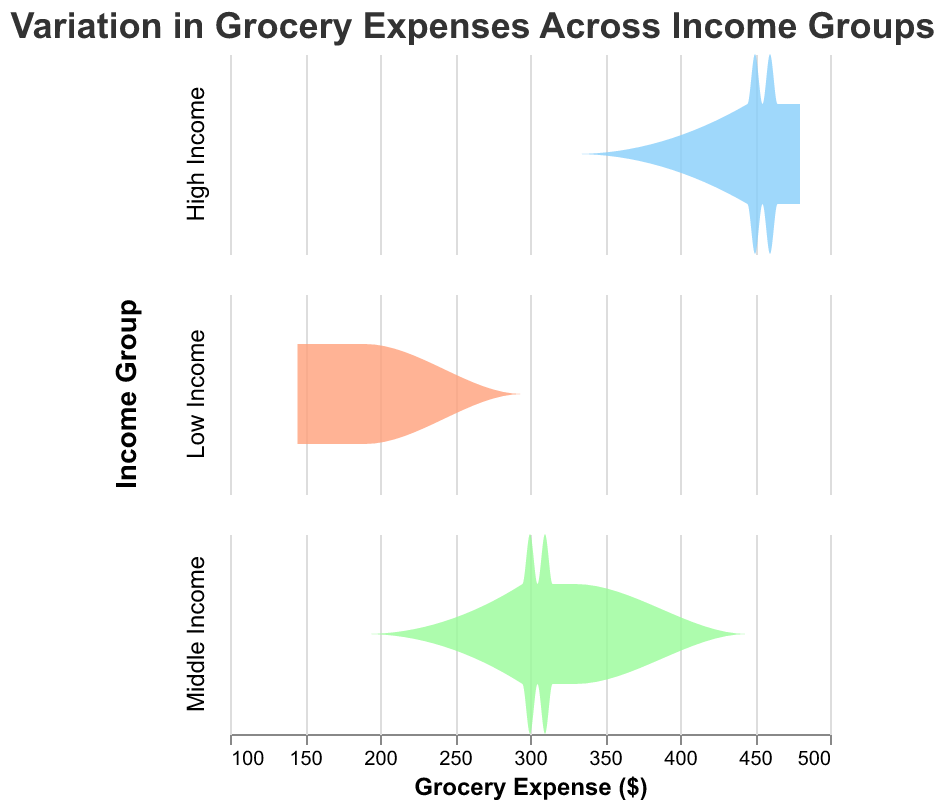What is the title of the figure? The title is usually found at the top of the figure. In this case, it’s indicated in the code as "Variation in Grocery Expenses Across Income Groups".
Answer: Variation in Grocery Expenses Across Income Groups How are the different income groups represented in the figure? The representation of different income groups can be seen through the color scheme and faceting. Each income group (Low Income, Middle Income, High Income) is represented by different colors and separate rows in the subplot.
Answer: By different colors and separate rows Which income group has the highest range of grocery expenses? The highest range can be identified by looking at the span of the distribution on the x-axis for each income group. The High Income group ranges from $445 to $480, which is the widest span compared to the other groups.
Answer: High Income What is the general range of grocery expenses for middle-income individuals based on the figure? By observing the distribution for the Middle Income group, the grocery expenses generally range from $295 to $330.
Answer: $295 to $330 Which income group appears to have the least variation in grocery expenses? The income group with the least variation would have the smallest spread in the density plot. The Low Income group has expenses ranging from $145 to $190, which is narrower compared to the other groups.
Answer: Low Income How do the peaks of the density plots differ between income groups? Peaks of density plots indicate where the most frequent grocery expense values lie. By comparing these peaks: Low Income peaks around $170, Middle Income peaks around $310, and High Income peaks around $460.
Answer: Low Income at ~$170, Middle Income at ~$310, High Income at ~$460 Among the three income groups, which one has the grocery expense value with the highest density? The group with the highest density would have the tallest peak in its density plot. Observing the figure, the High Income group's peak is the tallest at around $460.
Answer: High Income What can you infer about the relationship between income and grocery expenses from this figure? Higher income groups tend to have higher grocery expenses, as indicated by the rightward shift and higher values of the density plots for the High Income group compared to Low and Middle Income groups.
Answer: Higher income correlates with higher grocery expenses Is there any overlap in the grocery expense ranges of the different income groups? Overlap can be observed by checking if the density plots for different income groups share any common expense values on the x-axis. There is slight overlap between the higher end of Low Income and the lower end of Middle Income, but none with High Income.
Answer: Slight overlap between Low and Middle Income 